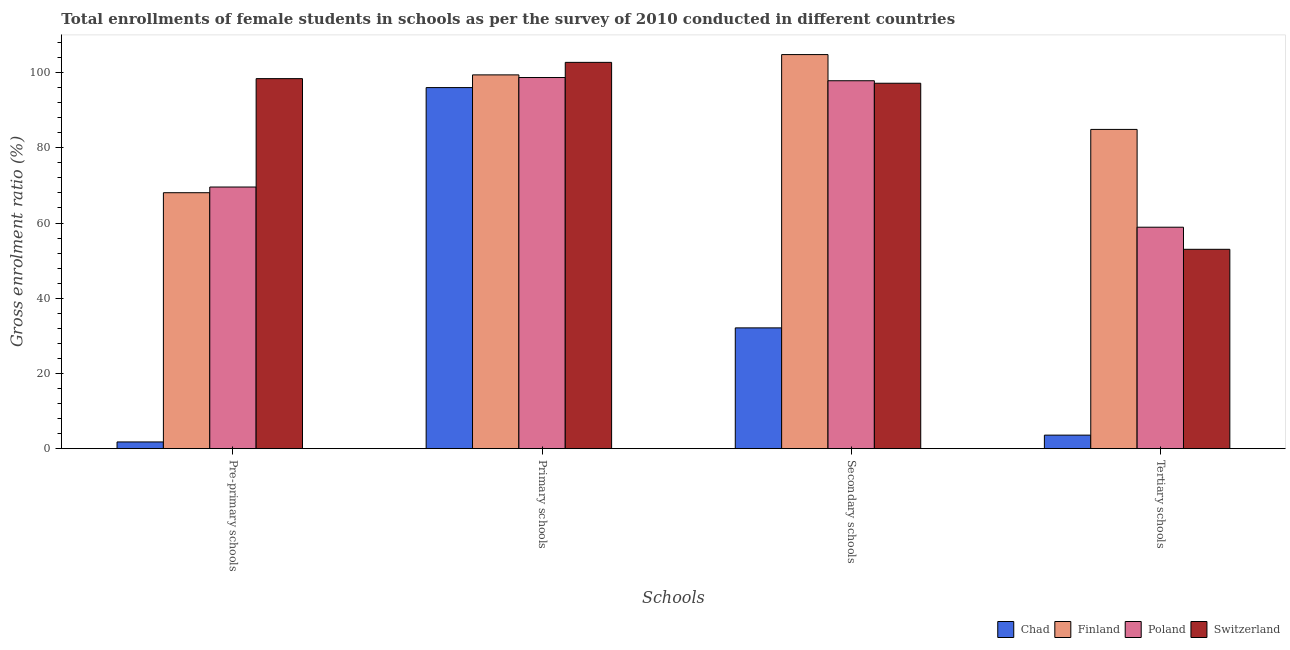How many groups of bars are there?
Offer a terse response. 4. Are the number of bars on each tick of the X-axis equal?
Offer a terse response. Yes. How many bars are there on the 2nd tick from the left?
Your answer should be compact. 4. What is the label of the 4th group of bars from the left?
Your response must be concise. Tertiary schools. What is the gross enrolment ratio(female) in secondary schools in Chad?
Offer a terse response. 32.12. Across all countries, what is the maximum gross enrolment ratio(female) in primary schools?
Your answer should be very brief. 102.72. Across all countries, what is the minimum gross enrolment ratio(female) in secondary schools?
Ensure brevity in your answer.  32.12. In which country was the gross enrolment ratio(female) in secondary schools minimum?
Your response must be concise. Chad. What is the total gross enrolment ratio(female) in secondary schools in the graph?
Your answer should be compact. 331.92. What is the difference between the gross enrolment ratio(female) in tertiary schools in Chad and that in Poland?
Give a very brief answer. -55.29. What is the difference between the gross enrolment ratio(female) in primary schools in Chad and the gross enrolment ratio(female) in pre-primary schools in Finland?
Your answer should be compact. 27.95. What is the average gross enrolment ratio(female) in pre-primary schools per country?
Keep it short and to the point. 59.45. What is the difference between the gross enrolment ratio(female) in pre-primary schools and gross enrolment ratio(female) in primary schools in Poland?
Keep it short and to the point. -29.12. What is the ratio of the gross enrolment ratio(female) in primary schools in Poland to that in Finland?
Give a very brief answer. 0.99. Is the difference between the gross enrolment ratio(female) in primary schools in Chad and Poland greater than the difference between the gross enrolment ratio(female) in pre-primary schools in Chad and Poland?
Your answer should be compact. Yes. What is the difference between the highest and the second highest gross enrolment ratio(female) in pre-primary schools?
Keep it short and to the point. 28.82. What is the difference between the highest and the lowest gross enrolment ratio(female) in primary schools?
Offer a terse response. 6.71. In how many countries, is the gross enrolment ratio(female) in pre-primary schools greater than the average gross enrolment ratio(female) in pre-primary schools taken over all countries?
Make the answer very short. 3. Is the sum of the gross enrolment ratio(female) in secondary schools in Chad and Switzerland greater than the maximum gross enrolment ratio(female) in primary schools across all countries?
Your answer should be very brief. Yes. What does the 4th bar from the left in Secondary schools represents?
Provide a short and direct response. Switzerland. What does the 2nd bar from the right in Pre-primary schools represents?
Give a very brief answer. Poland. Are all the bars in the graph horizontal?
Provide a short and direct response. No. What is the difference between two consecutive major ticks on the Y-axis?
Give a very brief answer. 20. Are the values on the major ticks of Y-axis written in scientific E-notation?
Offer a very short reply. No. How many legend labels are there?
Your answer should be very brief. 4. What is the title of the graph?
Your answer should be compact. Total enrollments of female students in schools as per the survey of 2010 conducted in different countries. Does "Hong Kong" appear as one of the legend labels in the graph?
Ensure brevity in your answer.  No. What is the label or title of the X-axis?
Ensure brevity in your answer.  Schools. What is the Gross enrolment ratio (%) of Chad in Pre-primary schools?
Your answer should be very brief. 1.79. What is the Gross enrolment ratio (%) of Finland in Pre-primary schools?
Your response must be concise. 68.06. What is the Gross enrolment ratio (%) of Poland in Pre-primary schools?
Give a very brief answer. 69.57. What is the Gross enrolment ratio (%) of Switzerland in Pre-primary schools?
Provide a succinct answer. 98.39. What is the Gross enrolment ratio (%) in Chad in Primary schools?
Offer a terse response. 96.01. What is the Gross enrolment ratio (%) in Finland in Primary schools?
Your answer should be very brief. 99.39. What is the Gross enrolment ratio (%) of Poland in Primary schools?
Offer a terse response. 98.69. What is the Gross enrolment ratio (%) in Switzerland in Primary schools?
Offer a terse response. 102.72. What is the Gross enrolment ratio (%) of Chad in Secondary schools?
Your answer should be very brief. 32.12. What is the Gross enrolment ratio (%) of Finland in Secondary schools?
Your answer should be compact. 104.79. What is the Gross enrolment ratio (%) of Poland in Secondary schools?
Offer a very short reply. 97.84. What is the Gross enrolment ratio (%) of Switzerland in Secondary schools?
Keep it short and to the point. 97.17. What is the Gross enrolment ratio (%) of Chad in Tertiary schools?
Provide a short and direct response. 3.6. What is the Gross enrolment ratio (%) of Finland in Tertiary schools?
Your answer should be very brief. 84.89. What is the Gross enrolment ratio (%) in Poland in Tertiary schools?
Ensure brevity in your answer.  58.89. What is the Gross enrolment ratio (%) in Switzerland in Tertiary schools?
Keep it short and to the point. 53.01. Across all Schools, what is the maximum Gross enrolment ratio (%) of Chad?
Provide a short and direct response. 96.01. Across all Schools, what is the maximum Gross enrolment ratio (%) of Finland?
Ensure brevity in your answer.  104.79. Across all Schools, what is the maximum Gross enrolment ratio (%) of Poland?
Offer a terse response. 98.69. Across all Schools, what is the maximum Gross enrolment ratio (%) in Switzerland?
Your answer should be compact. 102.72. Across all Schools, what is the minimum Gross enrolment ratio (%) of Chad?
Keep it short and to the point. 1.79. Across all Schools, what is the minimum Gross enrolment ratio (%) of Finland?
Your answer should be compact. 68.06. Across all Schools, what is the minimum Gross enrolment ratio (%) of Poland?
Your answer should be very brief. 58.89. Across all Schools, what is the minimum Gross enrolment ratio (%) in Switzerland?
Make the answer very short. 53.01. What is the total Gross enrolment ratio (%) in Chad in the graph?
Ensure brevity in your answer.  133.52. What is the total Gross enrolment ratio (%) in Finland in the graph?
Your response must be concise. 357.14. What is the total Gross enrolment ratio (%) in Poland in the graph?
Your answer should be very brief. 324.99. What is the total Gross enrolment ratio (%) in Switzerland in the graph?
Make the answer very short. 351.29. What is the difference between the Gross enrolment ratio (%) of Chad in Pre-primary schools and that in Primary schools?
Keep it short and to the point. -94.22. What is the difference between the Gross enrolment ratio (%) of Finland in Pre-primary schools and that in Primary schools?
Ensure brevity in your answer.  -31.33. What is the difference between the Gross enrolment ratio (%) of Poland in Pre-primary schools and that in Primary schools?
Give a very brief answer. -29.12. What is the difference between the Gross enrolment ratio (%) of Switzerland in Pre-primary schools and that in Primary schools?
Your answer should be very brief. -4.33. What is the difference between the Gross enrolment ratio (%) in Chad in Pre-primary schools and that in Secondary schools?
Offer a very short reply. -30.33. What is the difference between the Gross enrolment ratio (%) in Finland in Pre-primary schools and that in Secondary schools?
Give a very brief answer. -36.73. What is the difference between the Gross enrolment ratio (%) of Poland in Pre-primary schools and that in Secondary schools?
Offer a very short reply. -28.26. What is the difference between the Gross enrolment ratio (%) of Switzerland in Pre-primary schools and that in Secondary schools?
Your answer should be compact. 1.22. What is the difference between the Gross enrolment ratio (%) of Chad in Pre-primary schools and that in Tertiary schools?
Your answer should be compact. -1.81. What is the difference between the Gross enrolment ratio (%) of Finland in Pre-primary schools and that in Tertiary schools?
Make the answer very short. -16.83. What is the difference between the Gross enrolment ratio (%) of Poland in Pre-primary schools and that in Tertiary schools?
Your response must be concise. 10.69. What is the difference between the Gross enrolment ratio (%) in Switzerland in Pre-primary schools and that in Tertiary schools?
Offer a terse response. 45.38. What is the difference between the Gross enrolment ratio (%) of Chad in Primary schools and that in Secondary schools?
Your answer should be very brief. 63.89. What is the difference between the Gross enrolment ratio (%) of Finland in Primary schools and that in Secondary schools?
Provide a succinct answer. -5.4. What is the difference between the Gross enrolment ratio (%) of Poland in Primary schools and that in Secondary schools?
Keep it short and to the point. 0.86. What is the difference between the Gross enrolment ratio (%) in Switzerland in Primary schools and that in Secondary schools?
Provide a succinct answer. 5.55. What is the difference between the Gross enrolment ratio (%) in Chad in Primary schools and that in Tertiary schools?
Provide a succinct answer. 92.41. What is the difference between the Gross enrolment ratio (%) in Finland in Primary schools and that in Tertiary schools?
Your answer should be very brief. 14.5. What is the difference between the Gross enrolment ratio (%) of Poland in Primary schools and that in Tertiary schools?
Your answer should be very brief. 39.8. What is the difference between the Gross enrolment ratio (%) of Switzerland in Primary schools and that in Tertiary schools?
Give a very brief answer. 49.71. What is the difference between the Gross enrolment ratio (%) in Chad in Secondary schools and that in Tertiary schools?
Your response must be concise. 28.52. What is the difference between the Gross enrolment ratio (%) of Finland in Secondary schools and that in Tertiary schools?
Offer a terse response. 19.9. What is the difference between the Gross enrolment ratio (%) in Poland in Secondary schools and that in Tertiary schools?
Provide a succinct answer. 38.95. What is the difference between the Gross enrolment ratio (%) in Switzerland in Secondary schools and that in Tertiary schools?
Your response must be concise. 44.15. What is the difference between the Gross enrolment ratio (%) in Chad in Pre-primary schools and the Gross enrolment ratio (%) in Finland in Primary schools?
Offer a terse response. -97.6. What is the difference between the Gross enrolment ratio (%) of Chad in Pre-primary schools and the Gross enrolment ratio (%) of Poland in Primary schools?
Offer a terse response. -96.9. What is the difference between the Gross enrolment ratio (%) in Chad in Pre-primary schools and the Gross enrolment ratio (%) in Switzerland in Primary schools?
Your answer should be compact. -100.93. What is the difference between the Gross enrolment ratio (%) of Finland in Pre-primary schools and the Gross enrolment ratio (%) of Poland in Primary schools?
Your answer should be very brief. -30.63. What is the difference between the Gross enrolment ratio (%) in Finland in Pre-primary schools and the Gross enrolment ratio (%) in Switzerland in Primary schools?
Your answer should be compact. -34.66. What is the difference between the Gross enrolment ratio (%) in Poland in Pre-primary schools and the Gross enrolment ratio (%) in Switzerland in Primary schools?
Your response must be concise. -33.15. What is the difference between the Gross enrolment ratio (%) in Chad in Pre-primary schools and the Gross enrolment ratio (%) in Finland in Secondary schools?
Give a very brief answer. -103. What is the difference between the Gross enrolment ratio (%) in Chad in Pre-primary schools and the Gross enrolment ratio (%) in Poland in Secondary schools?
Provide a succinct answer. -96.05. What is the difference between the Gross enrolment ratio (%) of Chad in Pre-primary schools and the Gross enrolment ratio (%) of Switzerland in Secondary schools?
Your response must be concise. -95.38. What is the difference between the Gross enrolment ratio (%) in Finland in Pre-primary schools and the Gross enrolment ratio (%) in Poland in Secondary schools?
Your answer should be very brief. -29.77. What is the difference between the Gross enrolment ratio (%) in Finland in Pre-primary schools and the Gross enrolment ratio (%) in Switzerland in Secondary schools?
Ensure brevity in your answer.  -29.11. What is the difference between the Gross enrolment ratio (%) of Poland in Pre-primary schools and the Gross enrolment ratio (%) of Switzerland in Secondary schools?
Your answer should be compact. -27.6. What is the difference between the Gross enrolment ratio (%) of Chad in Pre-primary schools and the Gross enrolment ratio (%) of Finland in Tertiary schools?
Offer a terse response. -83.11. What is the difference between the Gross enrolment ratio (%) in Chad in Pre-primary schools and the Gross enrolment ratio (%) in Poland in Tertiary schools?
Keep it short and to the point. -57.1. What is the difference between the Gross enrolment ratio (%) of Chad in Pre-primary schools and the Gross enrolment ratio (%) of Switzerland in Tertiary schools?
Provide a succinct answer. -51.22. What is the difference between the Gross enrolment ratio (%) in Finland in Pre-primary schools and the Gross enrolment ratio (%) in Poland in Tertiary schools?
Offer a very short reply. 9.18. What is the difference between the Gross enrolment ratio (%) in Finland in Pre-primary schools and the Gross enrolment ratio (%) in Switzerland in Tertiary schools?
Your response must be concise. 15.05. What is the difference between the Gross enrolment ratio (%) in Poland in Pre-primary schools and the Gross enrolment ratio (%) in Switzerland in Tertiary schools?
Your answer should be very brief. 16.56. What is the difference between the Gross enrolment ratio (%) of Chad in Primary schools and the Gross enrolment ratio (%) of Finland in Secondary schools?
Your answer should be compact. -8.78. What is the difference between the Gross enrolment ratio (%) of Chad in Primary schools and the Gross enrolment ratio (%) of Poland in Secondary schools?
Make the answer very short. -1.82. What is the difference between the Gross enrolment ratio (%) in Chad in Primary schools and the Gross enrolment ratio (%) in Switzerland in Secondary schools?
Provide a succinct answer. -1.16. What is the difference between the Gross enrolment ratio (%) of Finland in Primary schools and the Gross enrolment ratio (%) of Poland in Secondary schools?
Your response must be concise. 1.56. What is the difference between the Gross enrolment ratio (%) of Finland in Primary schools and the Gross enrolment ratio (%) of Switzerland in Secondary schools?
Offer a very short reply. 2.22. What is the difference between the Gross enrolment ratio (%) in Poland in Primary schools and the Gross enrolment ratio (%) in Switzerland in Secondary schools?
Offer a terse response. 1.52. What is the difference between the Gross enrolment ratio (%) in Chad in Primary schools and the Gross enrolment ratio (%) in Finland in Tertiary schools?
Keep it short and to the point. 11.12. What is the difference between the Gross enrolment ratio (%) of Chad in Primary schools and the Gross enrolment ratio (%) of Poland in Tertiary schools?
Offer a very short reply. 37.13. What is the difference between the Gross enrolment ratio (%) in Chad in Primary schools and the Gross enrolment ratio (%) in Switzerland in Tertiary schools?
Make the answer very short. 43. What is the difference between the Gross enrolment ratio (%) in Finland in Primary schools and the Gross enrolment ratio (%) in Poland in Tertiary schools?
Ensure brevity in your answer.  40.5. What is the difference between the Gross enrolment ratio (%) of Finland in Primary schools and the Gross enrolment ratio (%) of Switzerland in Tertiary schools?
Ensure brevity in your answer.  46.38. What is the difference between the Gross enrolment ratio (%) in Poland in Primary schools and the Gross enrolment ratio (%) in Switzerland in Tertiary schools?
Provide a succinct answer. 45.68. What is the difference between the Gross enrolment ratio (%) of Chad in Secondary schools and the Gross enrolment ratio (%) of Finland in Tertiary schools?
Offer a terse response. -52.77. What is the difference between the Gross enrolment ratio (%) in Chad in Secondary schools and the Gross enrolment ratio (%) in Poland in Tertiary schools?
Ensure brevity in your answer.  -26.77. What is the difference between the Gross enrolment ratio (%) in Chad in Secondary schools and the Gross enrolment ratio (%) in Switzerland in Tertiary schools?
Your answer should be compact. -20.89. What is the difference between the Gross enrolment ratio (%) in Finland in Secondary schools and the Gross enrolment ratio (%) in Poland in Tertiary schools?
Your answer should be compact. 45.9. What is the difference between the Gross enrolment ratio (%) of Finland in Secondary schools and the Gross enrolment ratio (%) of Switzerland in Tertiary schools?
Provide a succinct answer. 51.78. What is the difference between the Gross enrolment ratio (%) in Poland in Secondary schools and the Gross enrolment ratio (%) in Switzerland in Tertiary schools?
Offer a very short reply. 44.82. What is the average Gross enrolment ratio (%) of Chad per Schools?
Offer a terse response. 33.38. What is the average Gross enrolment ratio (%) of Finland per Schools?
Provide a succinct answer. 89.28. What is the average Gross enrolment ratio (%) in Poland per Schools?
Your response must be concise. 81.25. What is the average Gross enrolment ratio (%) in Switzerland per Schools?
Make the answer very short. 87.82. What is the difference between the Gross enrolment ratio (%) of Chad and Gross enrolment ratio (%) of Finland in Pre-primary schools?
Your answer should be very brief. -66.27. What is the difference between the Gross enrolment ratio (%) in Chad and Gross enrolment ratio (%) in Poland in Pre-primary schools?
Make the answer very short. -67.78. What is the difference between the Gross enrolment ratio (%) of Chad and Gross enrolment ratio (%) of Switzerland in Pre-primary schools?
Ensure brevity in your answer.  -96.6. What is the difference between the Gross enrolment ratio (%) of Finland and Gross enrolment ratio (%) of Poland in Pre-primary schools?
Offer a very short reply. -1.51. What is the difference between the Gross enrolment ratio (%) in Finland and Gross enrolment ratio (%) in Switzerland in Pre-primary schools?
Offer a very short reply. -30.33. What is the difference between the Gross enrolment ratio (%) in Poland and Gross enrolment ratio (%) in Switzerland in Pre-primary schools?
Give a very brief answer. -28.82. What is the difference between the Gross enrolment ratio (%) of Chad and Gross enrolment ratio (%) of Finland in Primary schools?
Ensure brevity in your answer.  -3.38. What is the difference between the Gross enrolment ratio (%) of Chad and Gross enrolment ratio (%) of Poland in Primary schools?
Keep it short and to the point. -2.68. What is the difference between the Gross enrolment ratio (%) of Chad and Gross enrolment ratio (%) of Switzerland in Primary schools?
Offer a very short reply. -6.71. What is the difference between the Gross enrolment ratio (%) in Finland and Gross enrolment ratio (%) in Poland in Primary schools?
Offer a very short reply. 0.7. What is the difference between the Gross enrolment ratio (%) of Finland and Gross enrolment ratio (%) of Switzerland in Primary schools?
Offer a terse response. -3.33. What is the difference between the Gross enrolment ratio (%) in Poland and Gross enrolment ratio (%) in Switzerland in Primary schools?
Offer a very short reply. -4.03. What is the difference between the Gross enrolment ratio (%) in Chad and Gross enrolment ratio (%) in Finland in Secondary schools?
Your answer should be compact. -72.67. What is the difference between the Gross enrolment ratio (%) of Chad and Gross enrolment ratio (%) of Poland in Secondary schools?
Make the answer very short. -65.72. What is the difference between the Gross enrolment ratio (%) in Chad and Gross enrolment ratio (%) in Switzerland in Secondary schools?
Provide a short and direct response. -65.05. What is the difference between the Gross enrolment ratio (%) in Finland and Gross enrolment ratio (%) in Poland in Secondary schools?
Provide a succinct answer. 6.95. What is the difference between the Gross enrolment ratio (%) in Finland and Gross enrolment ratio (%) in Switzerland in Secondary schools?
Make the answer very short. 7.62. What is the difference between the Gross enrolment ratio (%) in Poland and Gross enrolment ratio (%) in Switzerland in Secondary schools?
Make the answer very short. 0.67. What is the difference between the Gross enrolment ratio (%) of Chad and Gross enrolment ratio (%) of Finland in Tertiary schools?
Ensure brevity in your answer.  -81.29. What is the difference between the Gross enrolment ratio (%) of Chad and Gross enrolment ratio (%) of Poland in Tertiary schools?
Offer a terse response. -55.29. What is the difference between the Gross enrolment ratio (%) in Chad and Gross enrolment ratio (%) in Switzerland in Tertiary schools?
Keep it short and to the point. -49.41. What is the difference between the Gross enrolment ratio (%) in Finland and Gross enrolment ratio (%) in Poland in Tertiary schools?
Give a very brief answer. 26.01. What is the difference between the Gross enrolment ratio (%) of Finland and Gross enrolment ratio (%) of Switzerland in Tertiary schools?
Ensure brevity in your answer.  31.88. What is the difference between the Gross enrolment ratio (%) of Poland and Gross enrolment ratio (%) of Switzerland in Tertiary schools?
Give a very brief answer. 5.87. What is the ratio of the Gross enrolment ratio (%) in Chad in Pre-primary schools to that in Primary schools?
Keep it short and to the point. 0.02. What is the ratio of the Gross enrolment ratio (%) of Finland in Pre-primary schools to that in Primary schools?
Provide a succinct answer. 0.68. What is the ratio of the Gross enrolment ratio (%) of Poland in Pre-primary schools to that in Primary schools?
Keep it short and to the point. 0.7. What is the ratio of the Gross enrolment ratio (%) of Switzerland in Pre-primary schools to that in Primary schools?
Ensure brevity in your answer.  0.96. What is the ratio of the Gross enrolment ratio (%) in Chad in Pre-primary schools to that in Secondary schools?
Give a very brief answer. 0.06. What is the ratio of the Gross enrolment ratio (%) of Finland in Pre-primary schools to that in Secondary schools?
Provide a succinct answer. 0.65. What is the ratio of the Gross enrolment ratio (%) in Poland in Pre-primary schools to that in Secondary schools?
Provide a short and direct response. 0.71. What is the ratio of the Gross enrolment ratio (%) of Switzerland in Pre-primary schools to that in Secondary schools?
Offer a terse response. 1.01. What is the ratio of the Gross enrolment ratio (%) of Chad in Pre-primary schools to that in Tertiary schools?
Provide a short and direct response. 0.5. What is the ratio of the Gross enrolment ratio (%) in Finland in Pre-primary schools to that in Tertiary schools?
Your answer should be compact. 0.8. What is the ratio of the Gross enrolment ratio (%) in Poland in Pre-primary schools to that in Tertiary schools?
Your answer should be very brief. 1.18. What is the ratio of the Gross enrolment ratio (%) in Switzerland in Pre-primary schools to that in Tertiary schools?
Keep it short and to the point. 1.86. What is the ratio of the Gross enrolment ratio (%) of Chad in Primary schools to that in Secondary schools?
Your response must be concise. 2.99. What is the ratio of the Gross enrolment ratio (%) of Finland in Primary schools to that in Secondary schools?
Provide a succinct answer. 0.95. What is the ratio of the Gross enrolment ratio (%) in Poland in Primary schools to that in Secondary schools?
Your answer should be very brief. 1.01. What is the ratio of the Gross enrolment ratio (%) in Switzerland in Primary schools to that in Secondary schools?
Your answer should be compact. 1.06. What is the ratio of the Gross enrolment ratio (%) in Chad in Primary schools to that in Tertiary schools?
Your answer should be very brief. 26.67. What is the ratio of the Gross enrolment ratio (%) of Finland in Primary schools to that in Tertiary schools?
Provide a short and direct response. 1.17. What is the ratio of the Gross enrolment ratio (%) in Poland in Primary schools to that in Tertiary schools?
Keep it short and to the point. 1.68. What is the ratio of the Gross enrolment ratio (%) of Switzerland in Primary schools to that in Tertiary schools?
Provide a short and direct response. 1.94. What is the ratio of the Gross enrolment ratio (%) in Chad in Secondary schools to that in Tertiary schools?
Ensure brevity in your answer.  8.92. What is the ratio of the Gross enrolment ratio (%) in Finland in Secondary schools to that in Tertiary schools?
Give a very brief answer. 1.23. What is the ratio of the Gross enrolment ratio (%) of Poland in Secondary schools to that in Tertiary schools?
Your answer should be compact. 1.66. What is the ratio of the Gross enrolment ratio (%) in Switzerland in Secondary schools to that in Tertiary schools?
Offer a very short reply. 1.83. What is the difference between the highest and the second highest Gross enrolment ratio (%) of Chad?
Your answer should be compact. 63.89. What is the difference between the highest and the second highest Gross enrolment ratio (%) in Finland?
Offer a terse response. 5.4. What is the difference between the highest and the second highest Gross enrolment ratio (%) of Poland?
Your answer should be very brief. 0.86. What is the difference between the highest and the second highest Gross enrolment ratio (%) in Switzerland?
Your answer should be very brief. 4.33. What is the difference between the highest and the lowest Gross enrolment ratio (%) of Chad?
Keep it short and to the point. 94.22. What is the difference between the highest and the lowest Gross enrolment ratio (%) of Finland?
Keep it short and to the point. 36.73. What is the difference between the highest and the lowest Gross enrolment ratio (%) in Poland?
Provide a short and direct response. 39.8. What is the difference between the highest and the lowest Gross enrolment ratio (%) in Switzerland?
Provide a succinct answer. 49.71. 